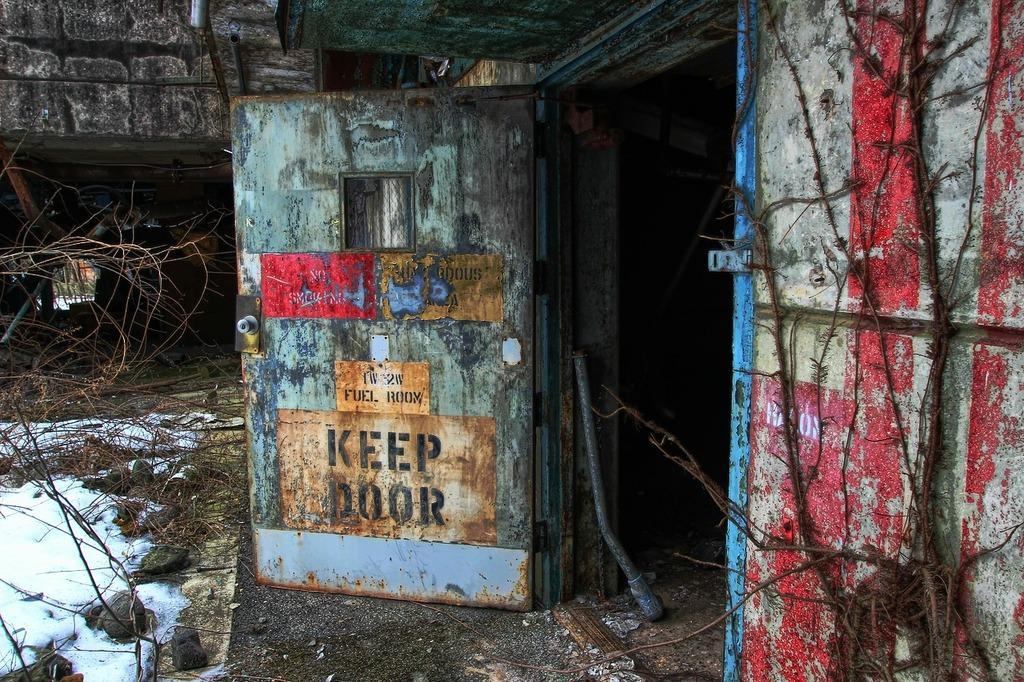Can you describe this image briefly? In this image we can see a door to the wall, there is a rod near the door and there are few sticks and stones on the ground. 